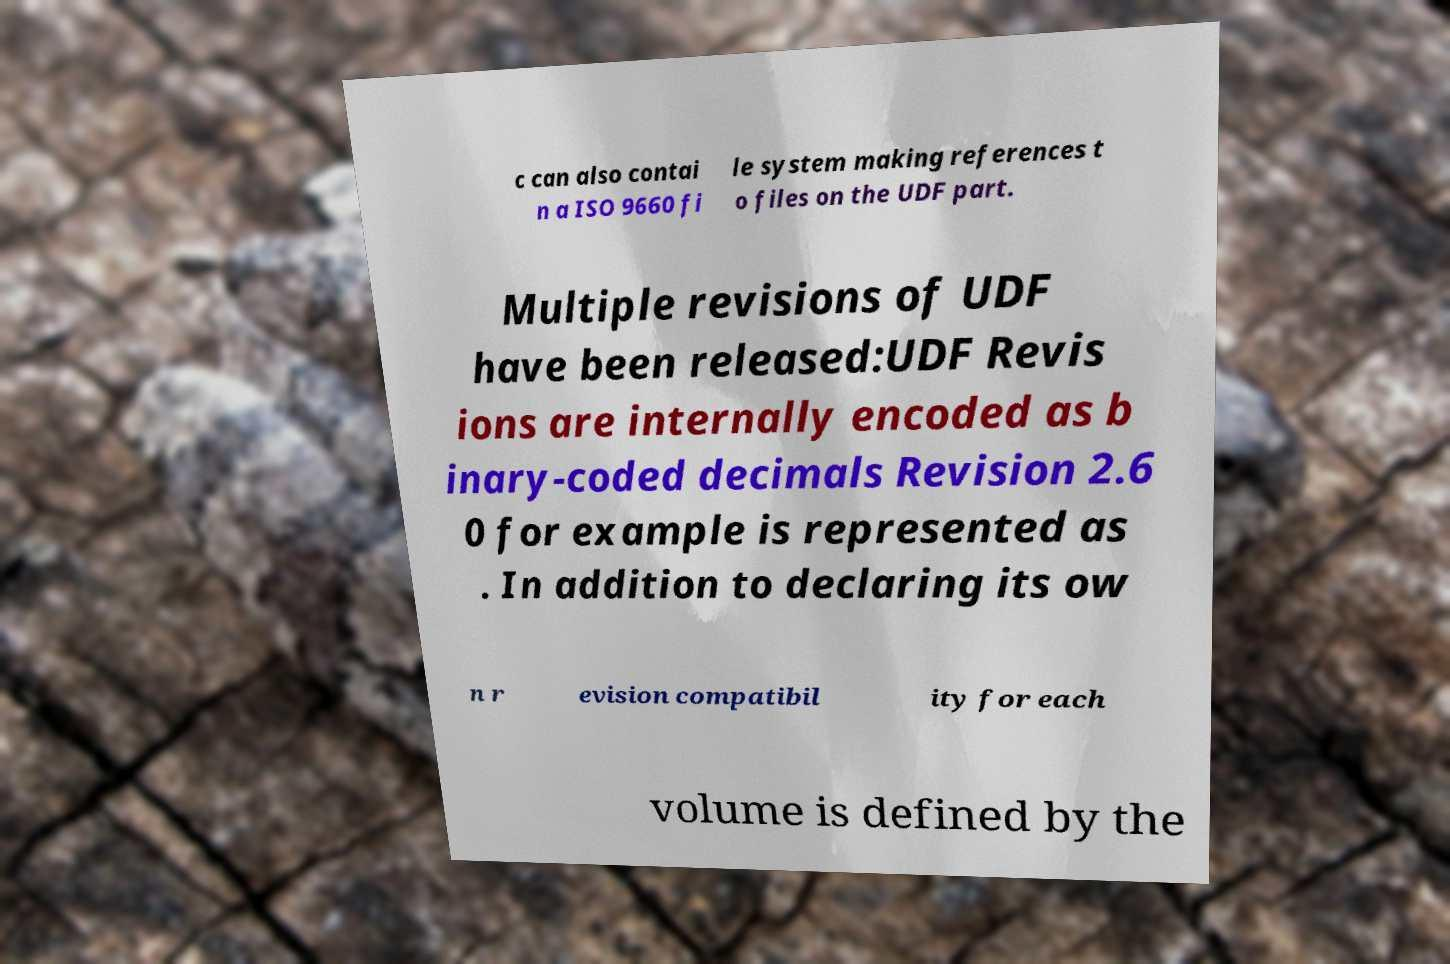Please read and relay the text visible in this image. What does it say? c can also contai n a ISO 9660 fi le system making references t o files on the UDF part. Multiple revisions of UDF have been released:UDF Revis ions are internally encoded as b inary-coded decimals Revision 2.6 0 for example is represented as . In addition to declaring its ow n r evision compatibil ity for each volume is defined by the 